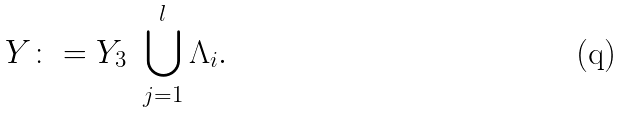Convert formula to latex. <formula><loc_0><loc_0><loc_500><loc_500>Y \colon = Y _ { 3 } \ \bigcup _ { j = 1 } ^ { l } \Lambda _ { i } .</formula> 